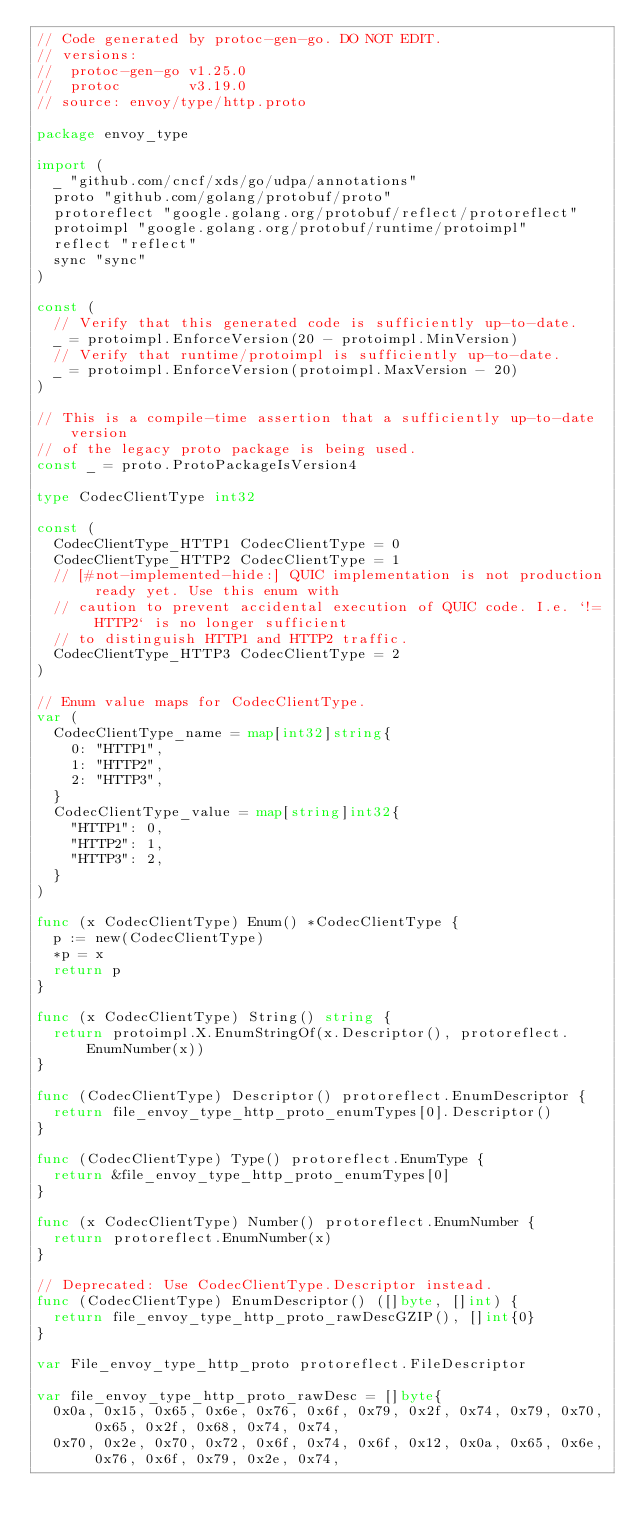<code> <loc_0><loc_0><loc_500><loc_500><_Go_>// Code generated by protoc-gen-go. DO NOT EDIT.
// versions:
// 	protoc-gen-go v1.25.0
// 	protoc        v3.19.0
// source: envoy/type/http.proto

package envoy_type

import (
	_ "github.com/cncf/xds/go/udpa/annotations"
	proto "github.com/golang/protobuf/proto"
	protoreflect "google.golang.org/protobuf/reflect/protoreflect"
	protoimpl "google.golang.org/protobuf/runtime/protoimpl"
	reflect "reflect"
	sync "sync"
)

const (
	// Verify that this generated code is sufficiently up-to-date.
	_ = protoimpl.EnforceVersion(20 - protoimpl.MinVersion)
	// Verify that runtime/protoimpl is sufficiently up-to-date.
	_ = protoimpl.EnforceVersion(protoimpl.MaxVersion - 20)
)

// This is a compile-time assertion that a sufficiently up-to-date version
// of the legacy proto package is being used.
const _ = proto.ProtoPackageIsVersion4

type CodecClientType int32

const (
	CodecClientType_HTTP1 CodecClientType = 0
	CodecClientType_HTTP2 CodecClientType = 1
	// [#not-implemented-hide:] QUIC implementation is not production ready yet. Use this enum with
	// caution to prevent accidental execution of QUIC code. I.e. `!= HTTP2` is no longer sufficient
	// to distinguish HTTP1 and HTTP2 traffic.
	CodecClientType_HTTP3 CodecClientType = 2
)

// Enum value maps for CodecClientType.
var (
	CodecClientType_name = map[int32]string{
		0: "HTTP1",
		1: "HTTP2",
		2: "HTTP3",
	}
	CodecClientType_value = map[string]int32{
		"HTTP1": 0,
		"HTTP2": 1,
		"HTTP3": 2,
	}
)

func (x CodecClientType) Enum() *CodecClientType {
	p := new(CodecClientType)
	*p = x
	return p
}

func (x CodecClientType) String() string {
	return protoimpl.X.EnumStringOf(x.Descriptor(), protoreflect.EnumNumber(x))
}

func (CodecClientType) Descriptor() protoreflect.EnumDescriptor {
	return file_envoy_type_http_proto_enumTypes[0].Descriptor()
}

func (CodecClientType) Type() protoreflect.EnumType {
	return &file_envoy_type_http_proto_enumTypes[0]
}

func (x CodecClientType) Number() protoreflect.EnumNumber {
	return protoreflect.EnumNumber(x)
}

// Deprecated: Use CodecClientType.Descriptor instead.
func (CodecClientType) EnumDescriptor() ([]byte, []int) {
	return file_envoy_type_http_proto_rawDescGZIP(), []int{0}
}

var File_envoy_type_http_proto protoreflect.FileDescriptor

var file_envoy_type_http_proto_rawDesc = []byte{
	0x0a, 0x15, 0x65, 0x6e, 0x76, 0x6f, 0x79, 0x2f, 0x74, 0x79, 0x70, 0x65, 0x2f, 0x68, 0x74, 0x74,
	0x70, 0x2e, 0x70, 0x72, 0x6f, 0x74, 0x6f, 0x12, 0x0a, 0x65, 0x6e, 0x76, 0x6f, 0x79, 0x2e, 0x74,</code> 